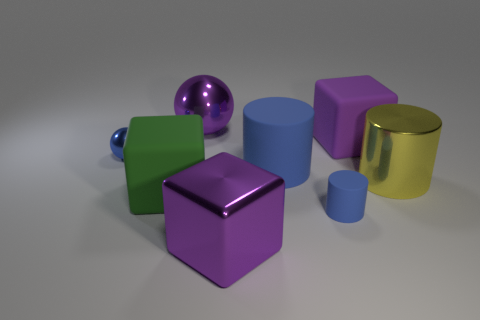Are there fewer big purple objects in front of the yellow cylinder than tiny things?
Give a very brief answer. Yes. What is the color of the large metal thing on the right side of the purple thing that is in front of the purple block that is behind the tiny blue shiny thing?
Your response must be concise. Yellow. What size is the other matte thing that is the same shape as the large blue thing?
Offer a very short reply. Small. Is the number of large rubber objects behind the big purple rubber thing less than the number of purple cubes behind the large blue cylinder?
Provide a succinct answer. Yes. What is the shape of the large purple thing that is both left of the big blue matte thing and behind the blue metal sphere?
Offer a very short reply. Sphere. There is another sphere that is the same material as the big ball; what size is it?
Provide a short and direct response. Small. There is a metallic cube; is it the same color as the large matte block behind the big green matte block?
Offer a terse response. Yes. There is a cube that is both in front of the big yellow shiny cylinder and on the right side of the purple metallic sphere; what material is it?
Offer a terse response. Metal. There is a shiny ball that is the same color as the small cylinder; what size is it?
Your answer should be very brief. Small. There is a purple object that is in front of the green matte cube; does it have the same shape as the purple object on the right side of the purple metallic cube?
Offer a very short reply. Yes. 